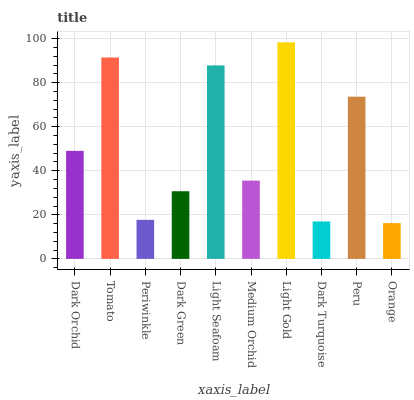Is Tomato the minimum?
Answer yes or no. No. Is Tomato the maximum?
Answer yes or no. No. Is Tomato greater than Dark Orchid?
Answer yes or no. Yes. Is Dark Orchid less than Tomato?
Answer yes or no. Yes. Is Dark Orchid greater than Tomato?
Answer yes or no. No. Is Tomato less than Dark Orchid?
Answer yes or no. No. Is Dark Orchid the high median?
Answer yes or no. Yes. Is Medium Orchid the low median?
Answer yes or no. Yes. Is Light Seafoam the high median?
Answer yes or no. No. Is Light Seafoam the low median?
Answer yes or no. No. 